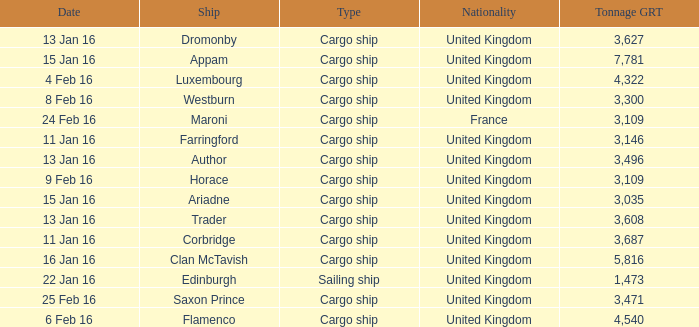What is the most tonnage grt of any ship sunk or captured on 16 jan 16? 5816.0. 